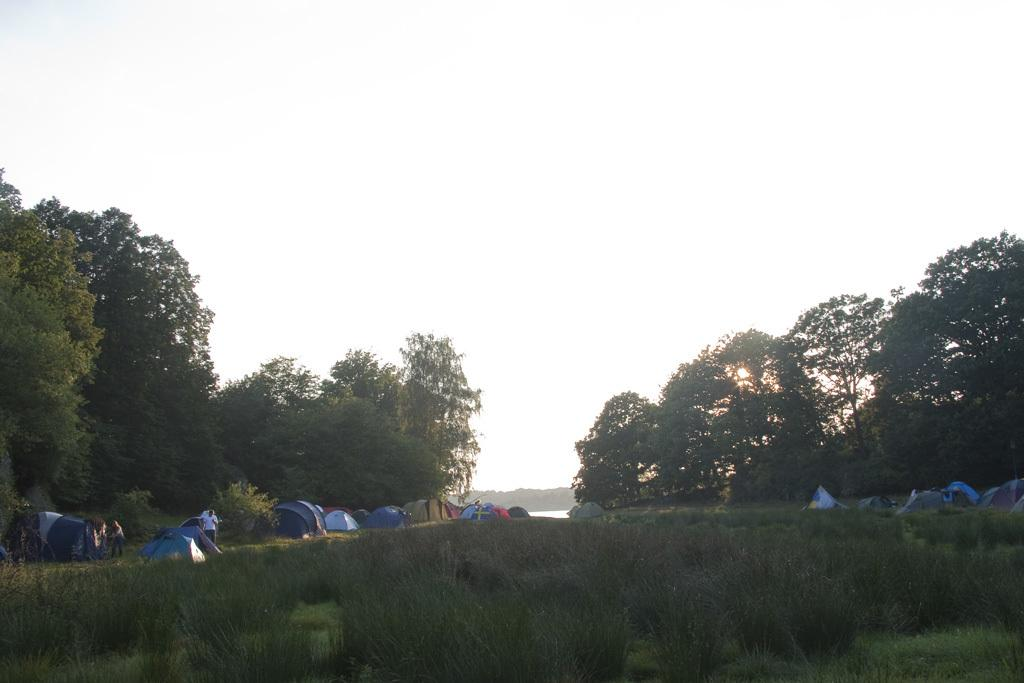What type of surface is visible in the image? There is grass on the surface in the image. What structures can be seen in the background of the image? There are tents in the background of the image. What are the people in the image doing? People are standing beside the tents. What other natural elements are visible in the background of the image? There are trees and water visible in the background of the image. What is the condition of the sky in the image? The sky is visible in the background of the image. Where is the mine located in the image? There is no mine present in the image. What type of wave can be seen crashing on the shore in the image? There is no wave or shore visible in the image; it features grass, tents, trees, water, and the sky. 